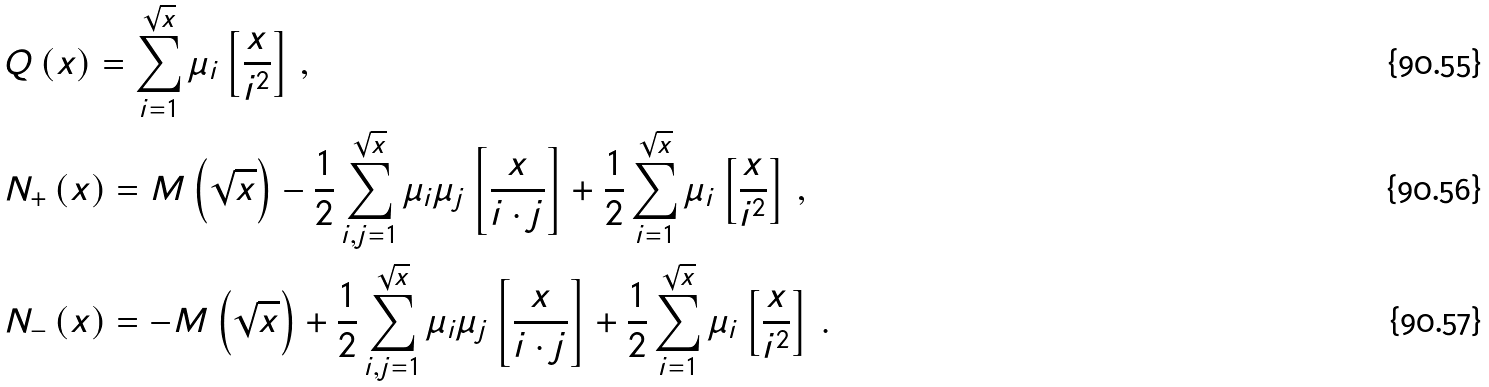Convert formula to latex. <formula><loc_0><loc_0><loc_500><loc_500>& Q \left ( x \right ) = \sum _ { i = 1 } ^ { \sqrt { x } } \mu _ { i } \left [ \frac { x } { i ^ { 2 } } \right ] \, , \\ & N _ { + } \left ( x \right ) = M \left ( \sqrt { x } \right ) - \frac { 1 } { 2 } \sum _ { i , j = 1 } ^ { \sqrt { x } } \mu _ { i } \mu _ { j } \left [ \frac { x } { i \cdot j } \right ] + \frac { 1 } { 2 } \sum _ { i = 1 } ^ { \sqrt { x } } \mu _ { i } \left [ \frac { x } { i ^ { 2 } } \right ] \, , \\ & N _ { - } \left ( x \right ) = - M \left ( \sqrt { x } \right ) + \frac { 1 } { 2 } \sum _ { i , j = 1 } ^ { \sqrt { x } } \mu _ { i } \mu _ { j } \left [ \frac { x } { i \cdot j } \right ] + \frac { 1 } { 2 } \sum _ { i = 1 } ^ { \sqrt { x } } \mu _ { i } \left [ \frac { x } { i ^ { 2 } } \right ] \, .</formula> 